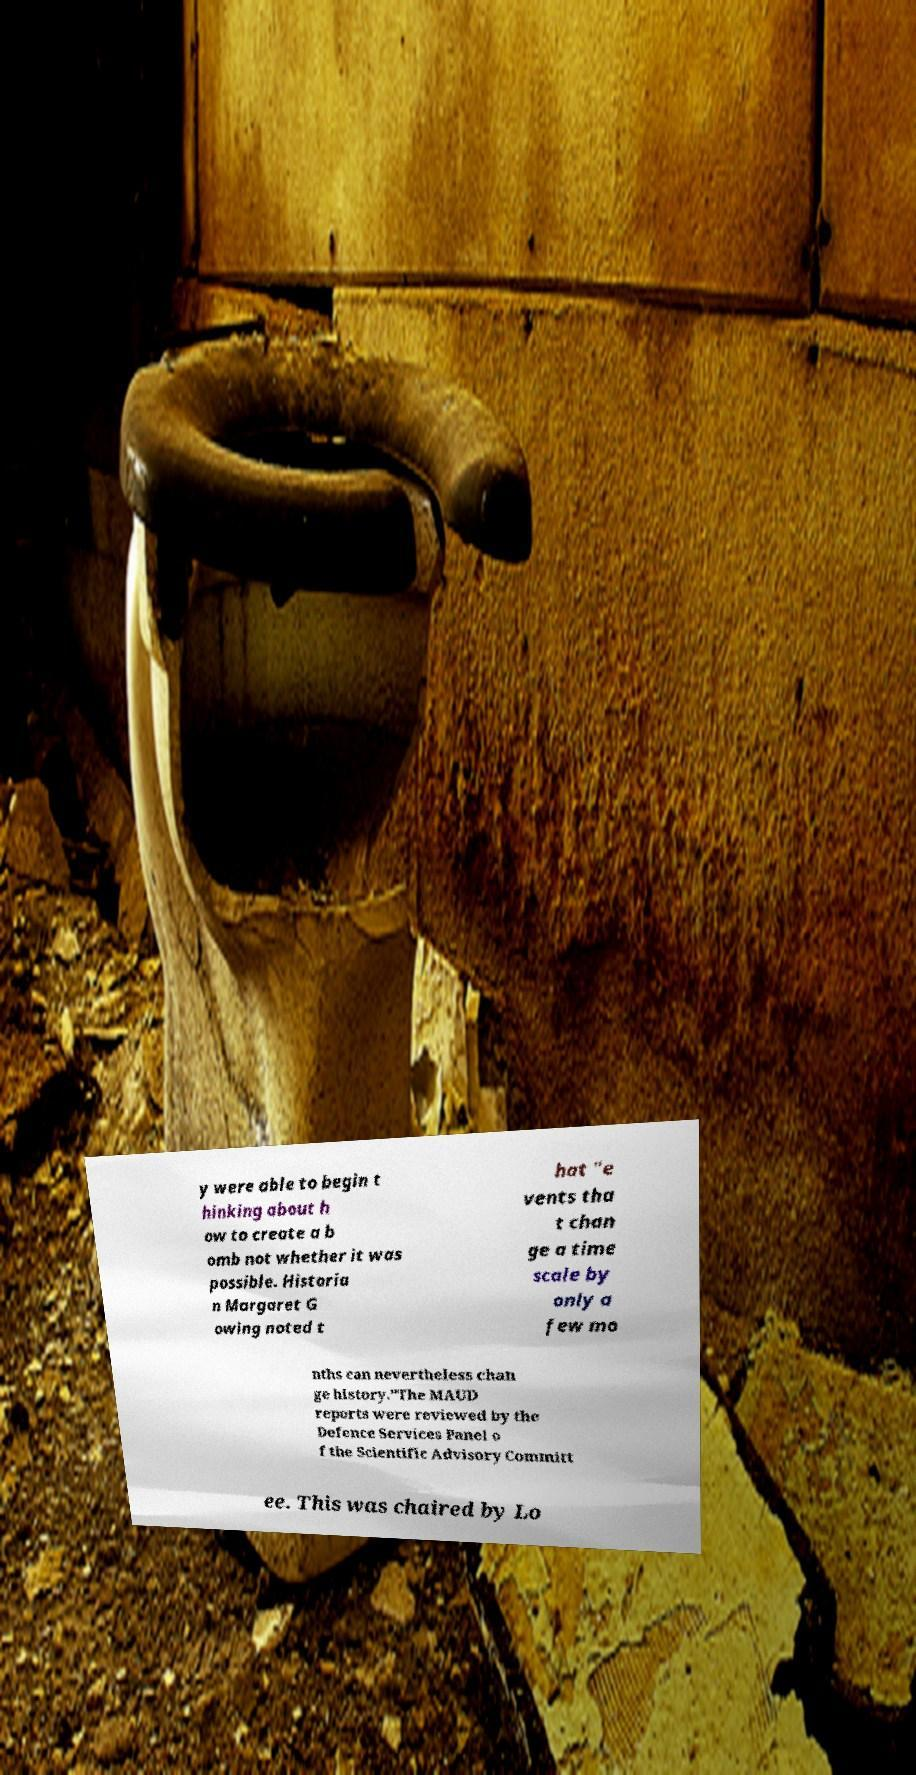For documentation purposes, I need the text within this image transcribed. Could you provide that? y were able to begin t hinking about h ow to create a b omb not whether it was possible. Historia n Margaret G owing noted t hat "e vents tha t chan ge a time scale by only a few mo nths can nevertheless chan ge history."The MAUD reports were reviewed by the Defence Services Panel o f the Scientific Advisory Committ ee. This was chaired by Lo 